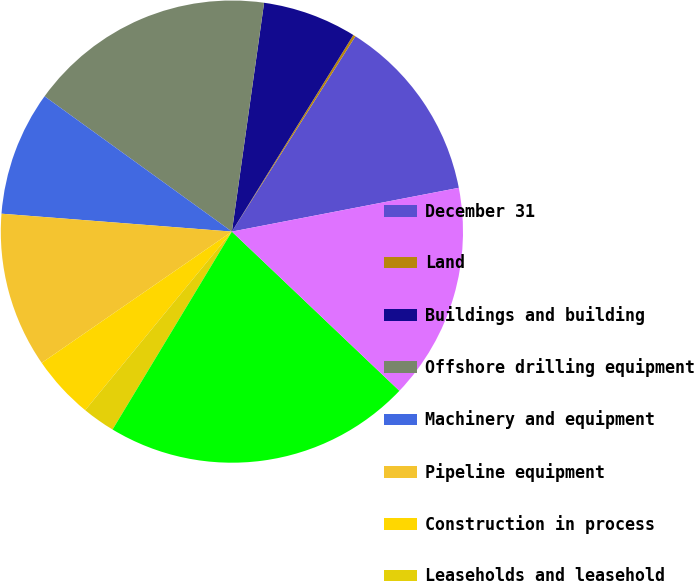Convert chart to OTSL. <chart><loc_0><loc_0><loc_500><loc_500><pie_chart><fcel>December 31<fcel>Land<fcel>Buildings and building<fcel>Offshore drilling equipment<fcel>Machinery and equipment<fcel>Pipeline equipment<fcel>Construction in process<fcel>Leaseholds and leasehold<fcel>Total<fcel>Less accumulated depreciation<nl><fcel>12.99%<fcel>0.17%<fcel>6.58%<fcel>17.27%<fcel>8.72%<fcel>10.85%<fcel>4.44%<fcel>2.31%<fcel>21.54%<fcel>15.13%<nl></chart> 